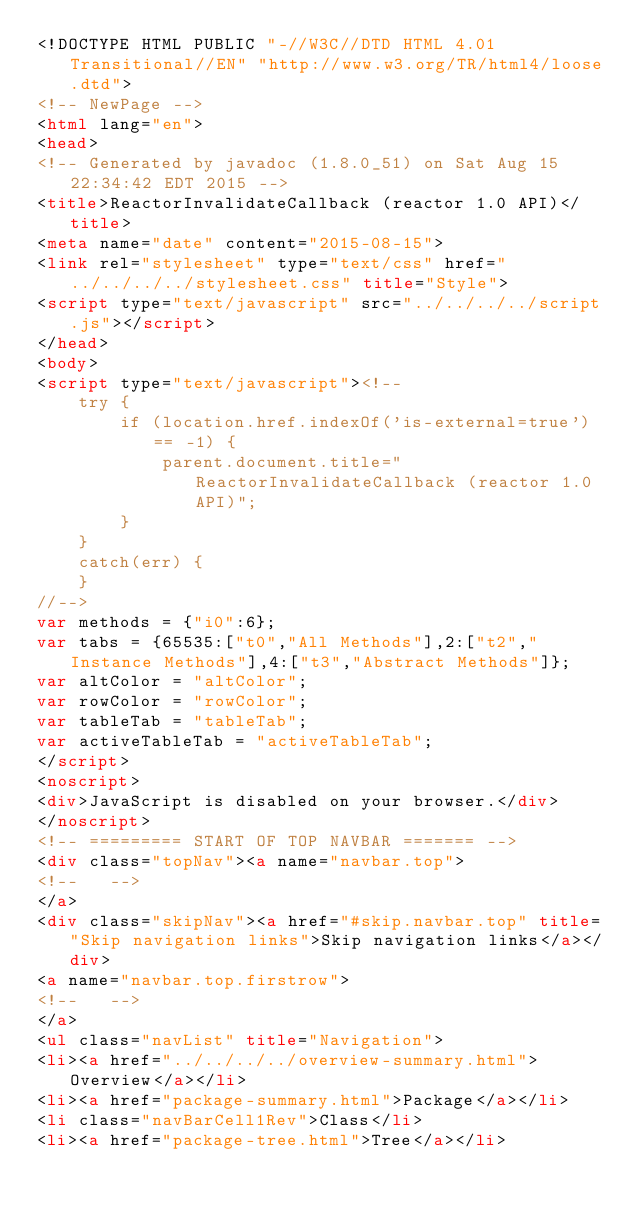Convert code to text. <code><loc_0><loc_0><loc_500><loc_500><_HTML_><!DOCTYPE HTML PUBLIC "-//W3C//DTD HTML 4.01 Transitional//EN" "http://www.w3.org/TR/html4/loose.dtd">
<!-- NewPage -->
<html lang="en">
<head>
<!-- Generated by javadoc (1.8.0_51) on Sat Aug 15 22:34:42 EDT 2015 -->
<title>ReactorInvalidateCallback (reactor 1.0 API)</title>
<meta name="date" content="2015-08-15">
<link rel="stylesheet" type="text/css" href="../../../../stylesheet.css" title="Style">
<script type="text/javascript" src="../../../../script.js"></script>
</head>
<body>
<script type="text/javascript"><!--
    try {
        if (location.href.indexOf('is-external=true') == -1) {
            parent.document.title="ReactorInvalidateCallback (reactor 1.0 API)";
        }
    }
    catch(err) {
    }
//-->
var methods = {"i0":6};
var tabs = {65535:["t0","All Methods"],2:["t2","Instance Methods"],4:["t3","Abstract Methods"]};
var altColor = "altColor";
var rowColor = "rowColor";
var tableTab = "tableTab";
var activeTableTab = "activeTableTab";
</script>
<noscript>
<div>JavaScript is disabled on your browser.</div>
</noscript>
<!-- ========= START OF TOP NAVBAR ======= -->
<div class="topNav"><a name="navbar.top">
<!--   -->
</a>
<div class="skipNav"><a href="#skip.navbar.top" title="Skip navigation links">Skip navigation links</a></div>
<a name="navbar.top.firstrow">
<!--   -->
</a>
<ul class="navList" title="Navigation">
<li><a href="../../../../overview-summary.html">Overview</a></li>
<li><a href="package-summary.html">Package</a></li>
<li class="navBarCell1Rev">Class</li>
<li><a href="package-tree.html">Tree</a></li></code> 